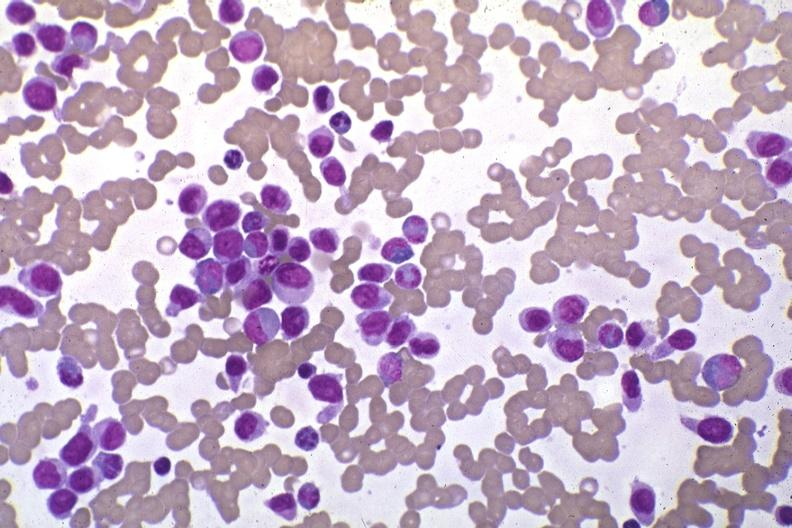what do wrights stain?
Answer the question using a single word or phrase. Pleomorphic leukemic cells in peripheral blood prior to therapy 